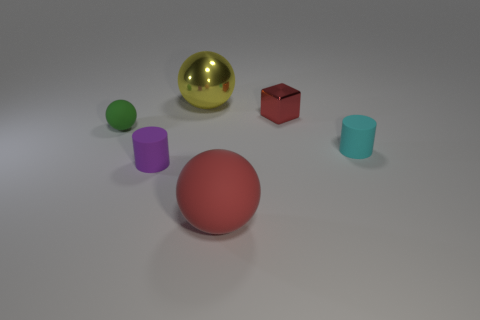Subtract all matte spheres. How many spheres are left? 1 Add 1 big matte spheres. How many objects exist? 7 Subtract all red balls. How many balls are left? 2 Subtract 2 balls. How many balls are left? 1 Subtract all gray balls. How many cyan cylinders are left? 1 Subtract all small blue blocks. Subtract all tiny objects. How many objects are left? 2 Add 6 cyan matte things. How many cyan matte things are left? 7 Add 5 small red objects. How many small red objects exist? 6 Subtract 1 green balls. How many objects are left? 5 Subtract all cubes. How many objects are left? 5 